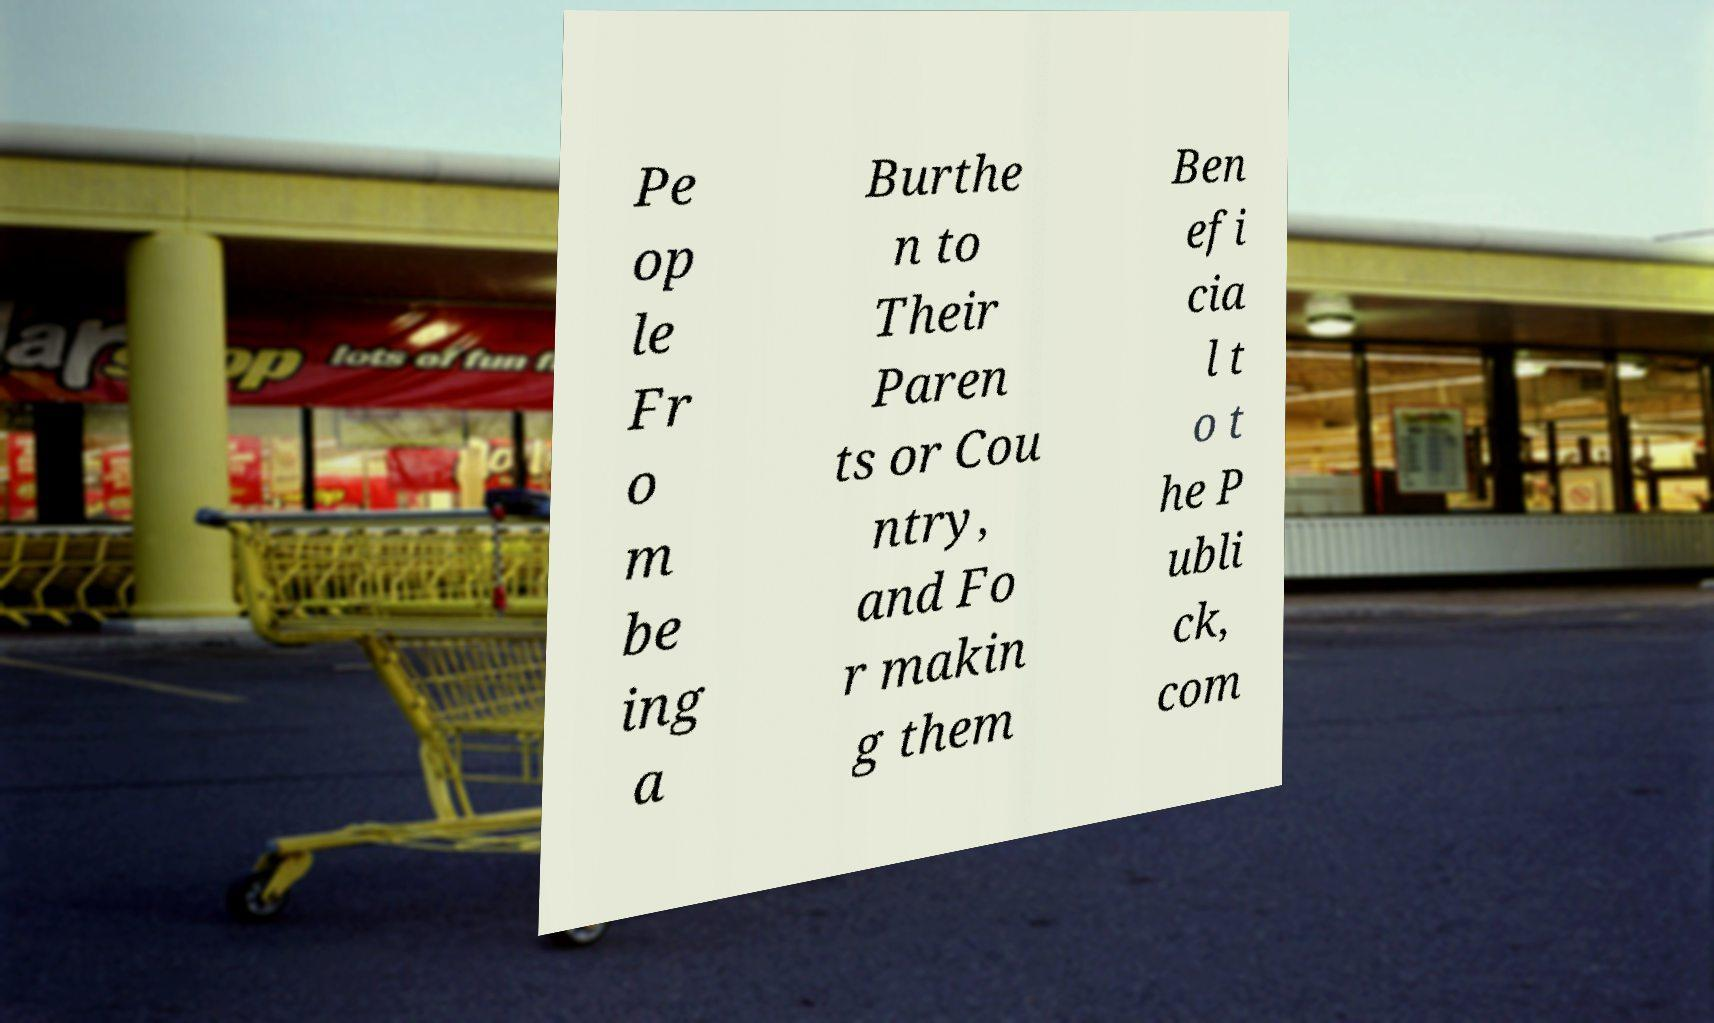There's text embedded in this image that I need extracted. Can you transcribe it verbatim? Pe op le Fr o m be ing a Burthe n to Their Paren ts or Cou ntry, and Fo r makin g them Ben efi cia l t o t he P ubli ck, com 